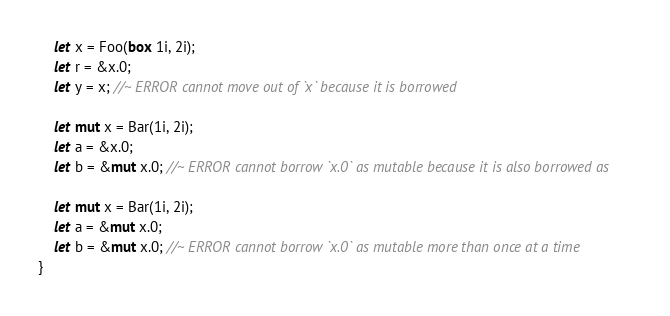Convert code to text. <code><loc_0><loc_0><loc_500><loc_500><_Rust_>
    let x = Foo(box 1i, 2i);
    let r = &x.0;
    let y = x; //~ ERROR cannot move out of `x` because it is borrowed

    let mut x = Bar(1i, 2i);
    let a = &x.0;
    let b = &mut x.0; //~ ERROR cannot borrow `x.0` as mutable because it is also borrowed as

    let mut x = Bar(1i, 2i);
    let a = &mut x.0;
    let b = &mut x.0; //~ ERROR cannot borrow `x.0` as mutable more than once at a time
}
</code> 